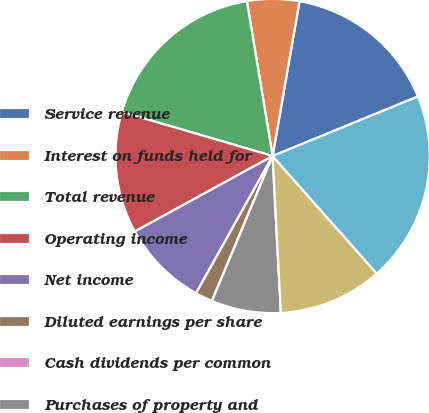<chart> <loc_0><loc_0><loc_500><loc_500><pie_chart><fcel>Service revenue<fcel>Interest on funds held for<fcel>Total revenue<fcel>Operating income<fcel>Net income<fcel>Diluted earnings per share<fcel>Cash dividends per common<fcel>Purchases of property and<fcel>Cash and total corporate<fcel>Total assets<nl><fcel>16.07%<fcel>5.36%<fcel>17.85%<fcel>12.5%<fcel>8.93%<fcel>1.79%<fcel>0.0%<fcel>7.14%<fcel>10.71%<fcel>19.64%<nl></chart> 